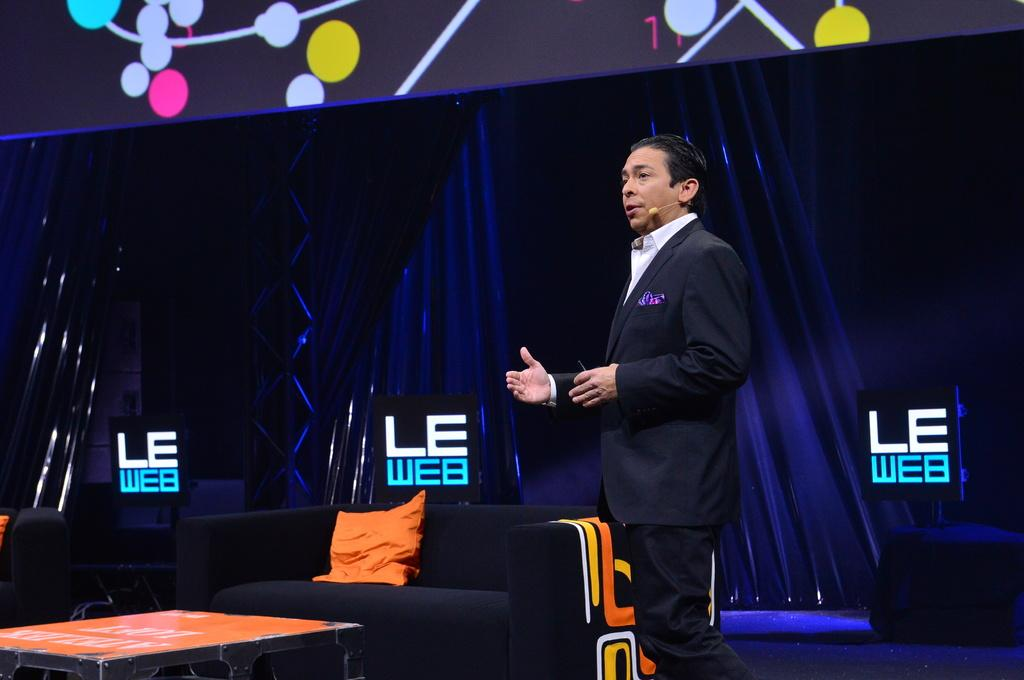<image>
Present a compact description of the photo's key features. A present gives a speech at the LE Web conference 